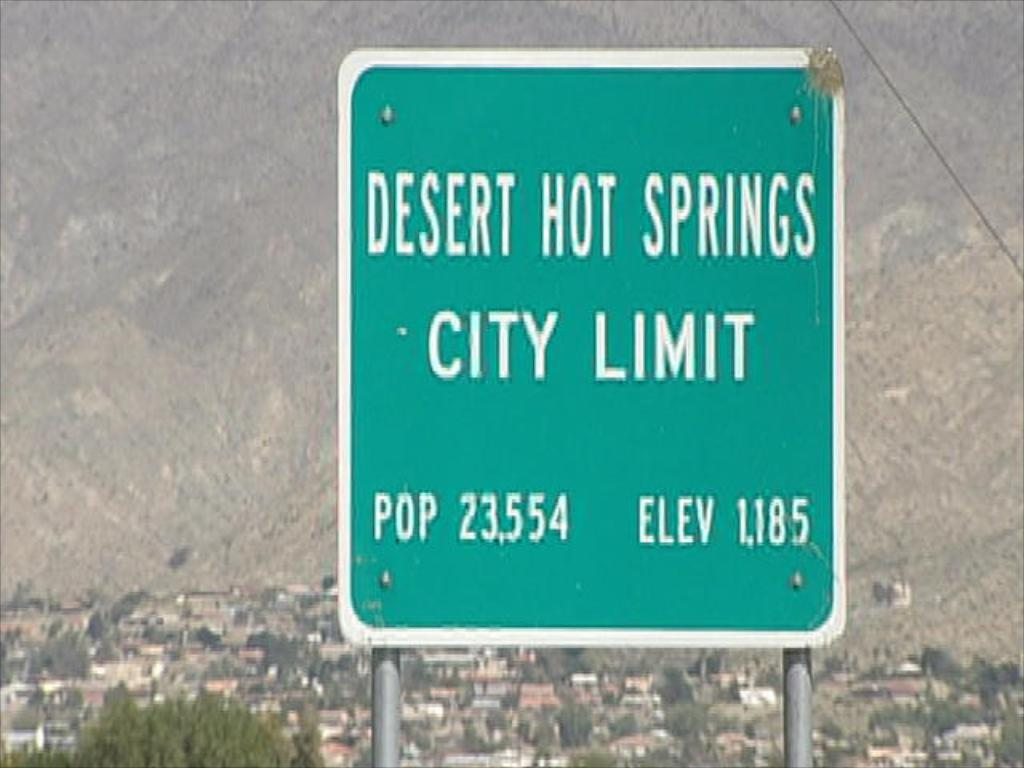<image>
Relay a brief, clear account of the picture shown. A population and elevation sign for Desert Hot Springs in front of the city. 